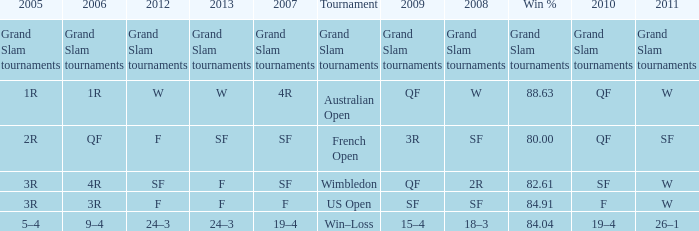What in 2013 has a 2009 of 3r? SF. 